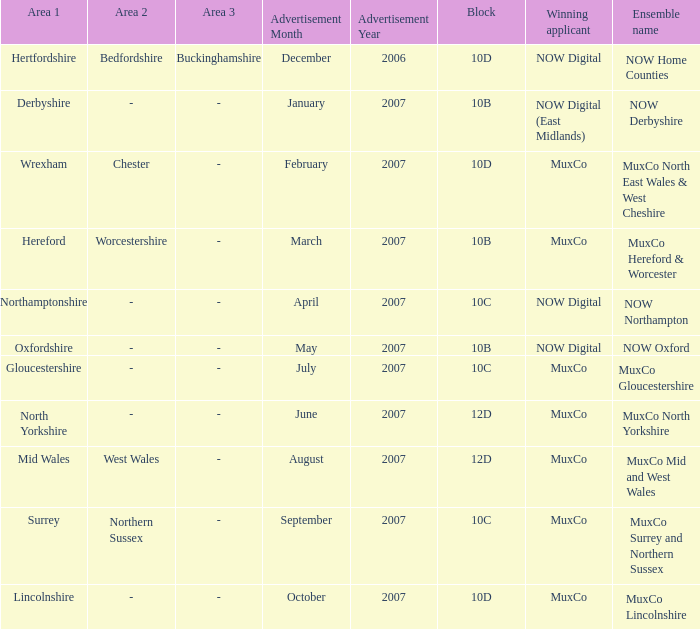Who is the Winning Applicant of Block 10B in Derbyshire Area? NOW Digital (East Midlands). 